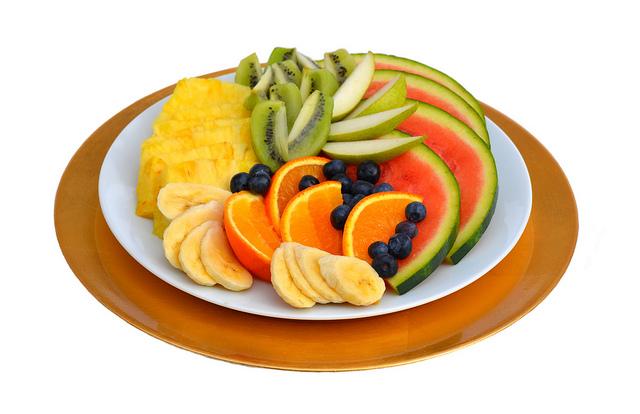How many crackers are in the photo?
Give a very brief answer. 0. What color is the center plate?
Quick response, please. White. How many different fruits on the plate?
Answer briefly. 7. Is this plastic item waterproof?
Quick response, please. Yes. How much does the plate weight?
Be succinct. 1 pound. 